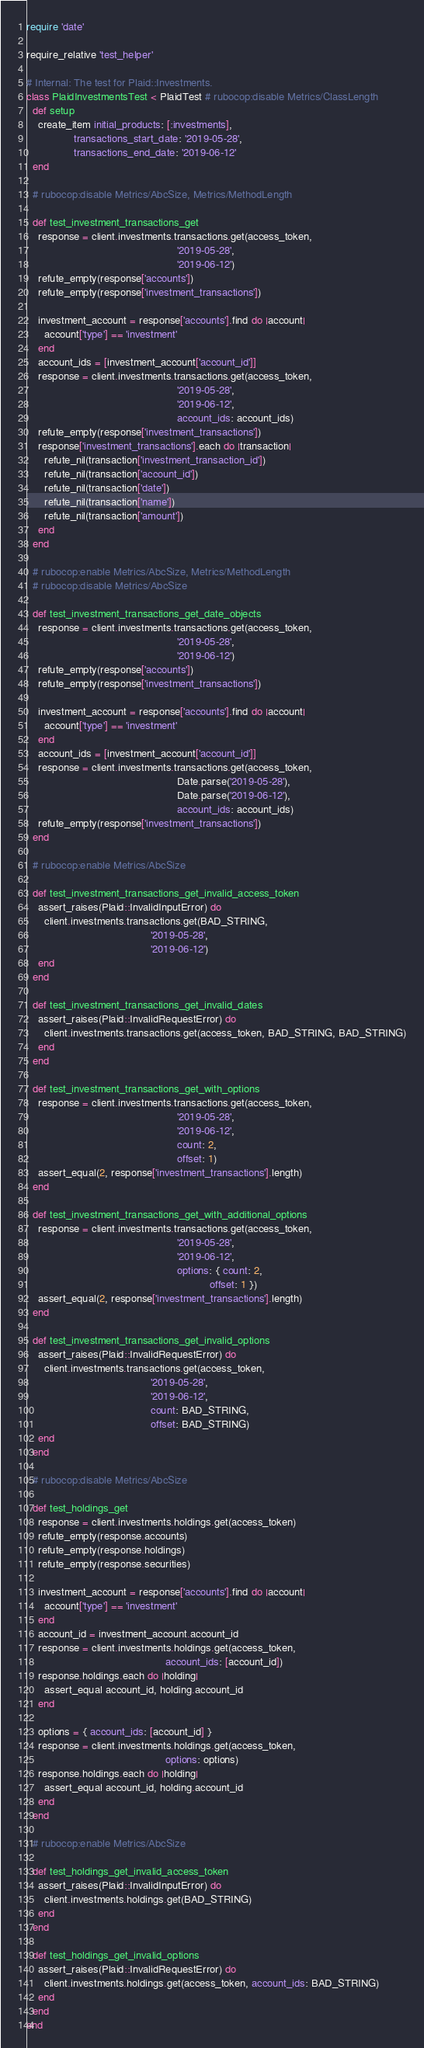Convert code to text. <code><loc_0><loc_0><loc_500><loc_500><_Ruby_>require 'date'

require_relative 'test_helper'

# Internal: The test for Plaid::Investments.
class PlaidInvestmentsTest < PlaidTest # rubocop:disable Metrics/ClassLength
  def setup
    create_item initial_products: [:investments],
                transactions_start_date: '2019-05-28',
                transactions_end_date: '2019-06-12'
  end

  # rubocop:disable Metrics/AbcSize, Metrics/MethodLength

  def test_investment_transactions_get
    response = client.investments.transactions.get(access_token,
                                                   '2019-05-28',
                                                   '2019-06-12')
    refute_empty(response['accounts'])
    refute_empty(response['investment_transactions'])

    investment_account = response['accounts'].find do |account|
      account['type'] == 'investment'
    end
    account_ids = [investment_account['account_id']]
    response = client.investments.transactions.get(access_token,
                                                   '2019-05-28',
                                                   '2019-06-12',
                                                   account_ids: account_ids)
    refute_empty(response['investment_transactions'])
    response['investment_transactions'].each do |transaction|
      refute_nil(transaction['investment_transaction_id'])
      refute_nil(transaction['account_id'])
      refute_nil(transaction['date'])
      refute_nil(transaction['name'])
      refute_nil(transaction['amount'])
    end
  end

  # rubocop:enable Metrics/AbcSize, Metrics/MethodLength
  # rubocop:disable Metrics/AbcSize

  def test_investment_transactions_get_date_objects
    response = client.investments.transactions.get(access_token,
                                                   '2019-05-28',
                                                   '2019-06-12')
    refute_empty(response['accounts'])
    refute_empty(response['investment_transactions'])

    investment_account = response['accounts'].find do |account|
      account['type'] == 'investment'
    end
    account_ids = [investment_account['account_id']]
    response = client.investments.transactions.get(access_token,
                                                   Date.parse('2019-05-28'),
                                                   Date.parse('2019-06-12'),
                                                   account_ids: account_ids)
    refute_empty(response['investment_transactions'])
  end

  # rubocop:enable Metrics/AbcSize

  def test_investment_transactions_get_invalid_access_token
    assert_raises(Plaid::InvalidInputError) do
      client.investments.transactions.get(BAD_STRING,
                                          '2019-05-28',
                                          '2019-06-12')
    end
  end

  def test_investment_transactions_get_invalid_dates
    assert_raises(Plaid::InvalidRequestError) do
      client.investments.transactions.get(access_token, BAD_STRING, BAD_STRING)
    end
  end

  def test_investment_transactions_get_with_options
    response = client.investments.transactions.get(access_token,
                                                   '2019-05-28',
                                                   '2019-06-12',
                                                   count: 2,
                                                   offset: 1)
    assert_equal(2, response['investment_transactions'].length)
  end

  def test_investment_transactions_get_with_additional_options
    response = client.investments.transactions.get(access_token,
                                                   '2019-05-28',
                                                   '2019-06-12',
                                                   options: { count: 2,
                                                              offset: 1 })
    assert_equal(2, response['investment_transactions'].length)
  end

  def test_investment_transactions_get_invalid_options
    assert_raises(Plaid::InvalidRequestError) do
      client.investments.transactions.get(access_token,
                                          '2019-05-28',
                                          '2019-06-12',
                                          count: BAD_STRING,
                                          offset: BAD_STRING)
    end
  end

  # rubocop:disable Metrics/AbcSize

  def test_holdings_get
    response = client.investments.holdings.get(access_token)
    refute_empty(response.accounts)
    refute_empty(response.holdings)
    refute_empty(response.securities)

    investment_account = response['accounts'].find do |account|
      account['type'] == 'investment'
    end
    account_id = investment_account.account_id
    response = client.investments.holdings.get(access_token,
                                               account_ids: [account_id])
    response.holdings.each do |holding|
      assert_equal account_id, holding.account_id
    end

    options = { account_ids: [account_id] }
    response = client.investments.holdings.get(access_token,
                                               options: options)
    response.holdings.each do |holding|
      assert_equal account_id, holding.account_id
    end
  end

  # rubocop:enable Metrics/AbcSize

  def test_holdings_get_invalid_access_token
    assert_raises(Plaid::InvalidInputError) do
      client.investments.holdings.get(BAD_STRING)
    end
  end

  def test_holdings_get_invalid_options
    assert_raises(Plaid::InvalidRequestError) do
      client.investments.holdings.get(access_token, account_ids: BAD_STRING)
    end
  end
end
</code> 